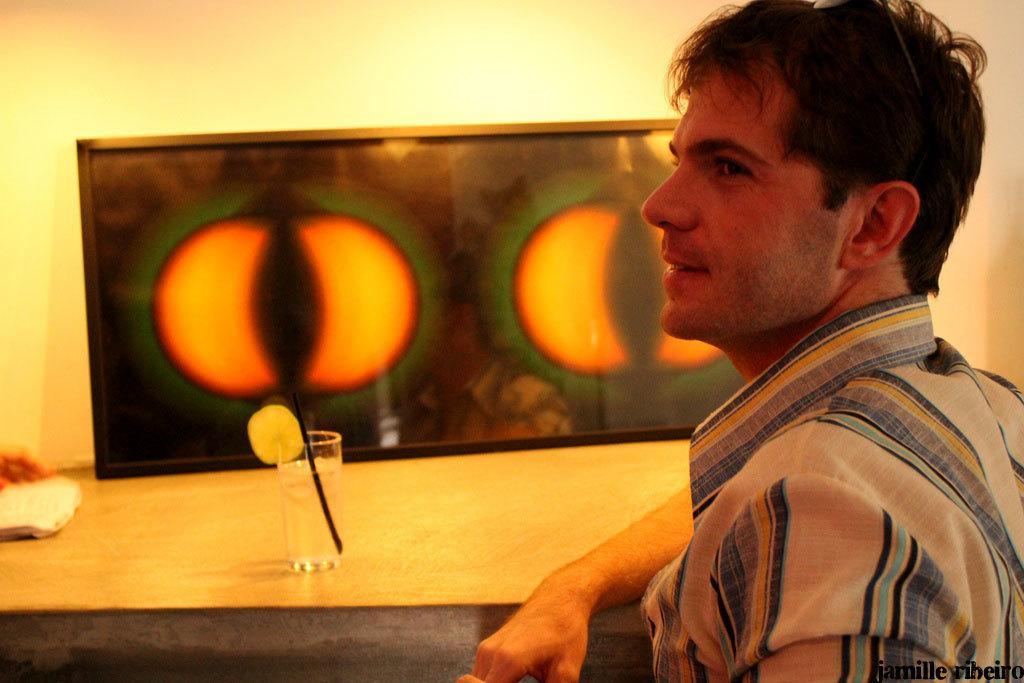Could you give a brief overview of what you see in this image? In this picture I can see a person in front of the table on which we can see a glass with straw and also we can see frame to the wall. 